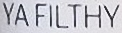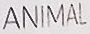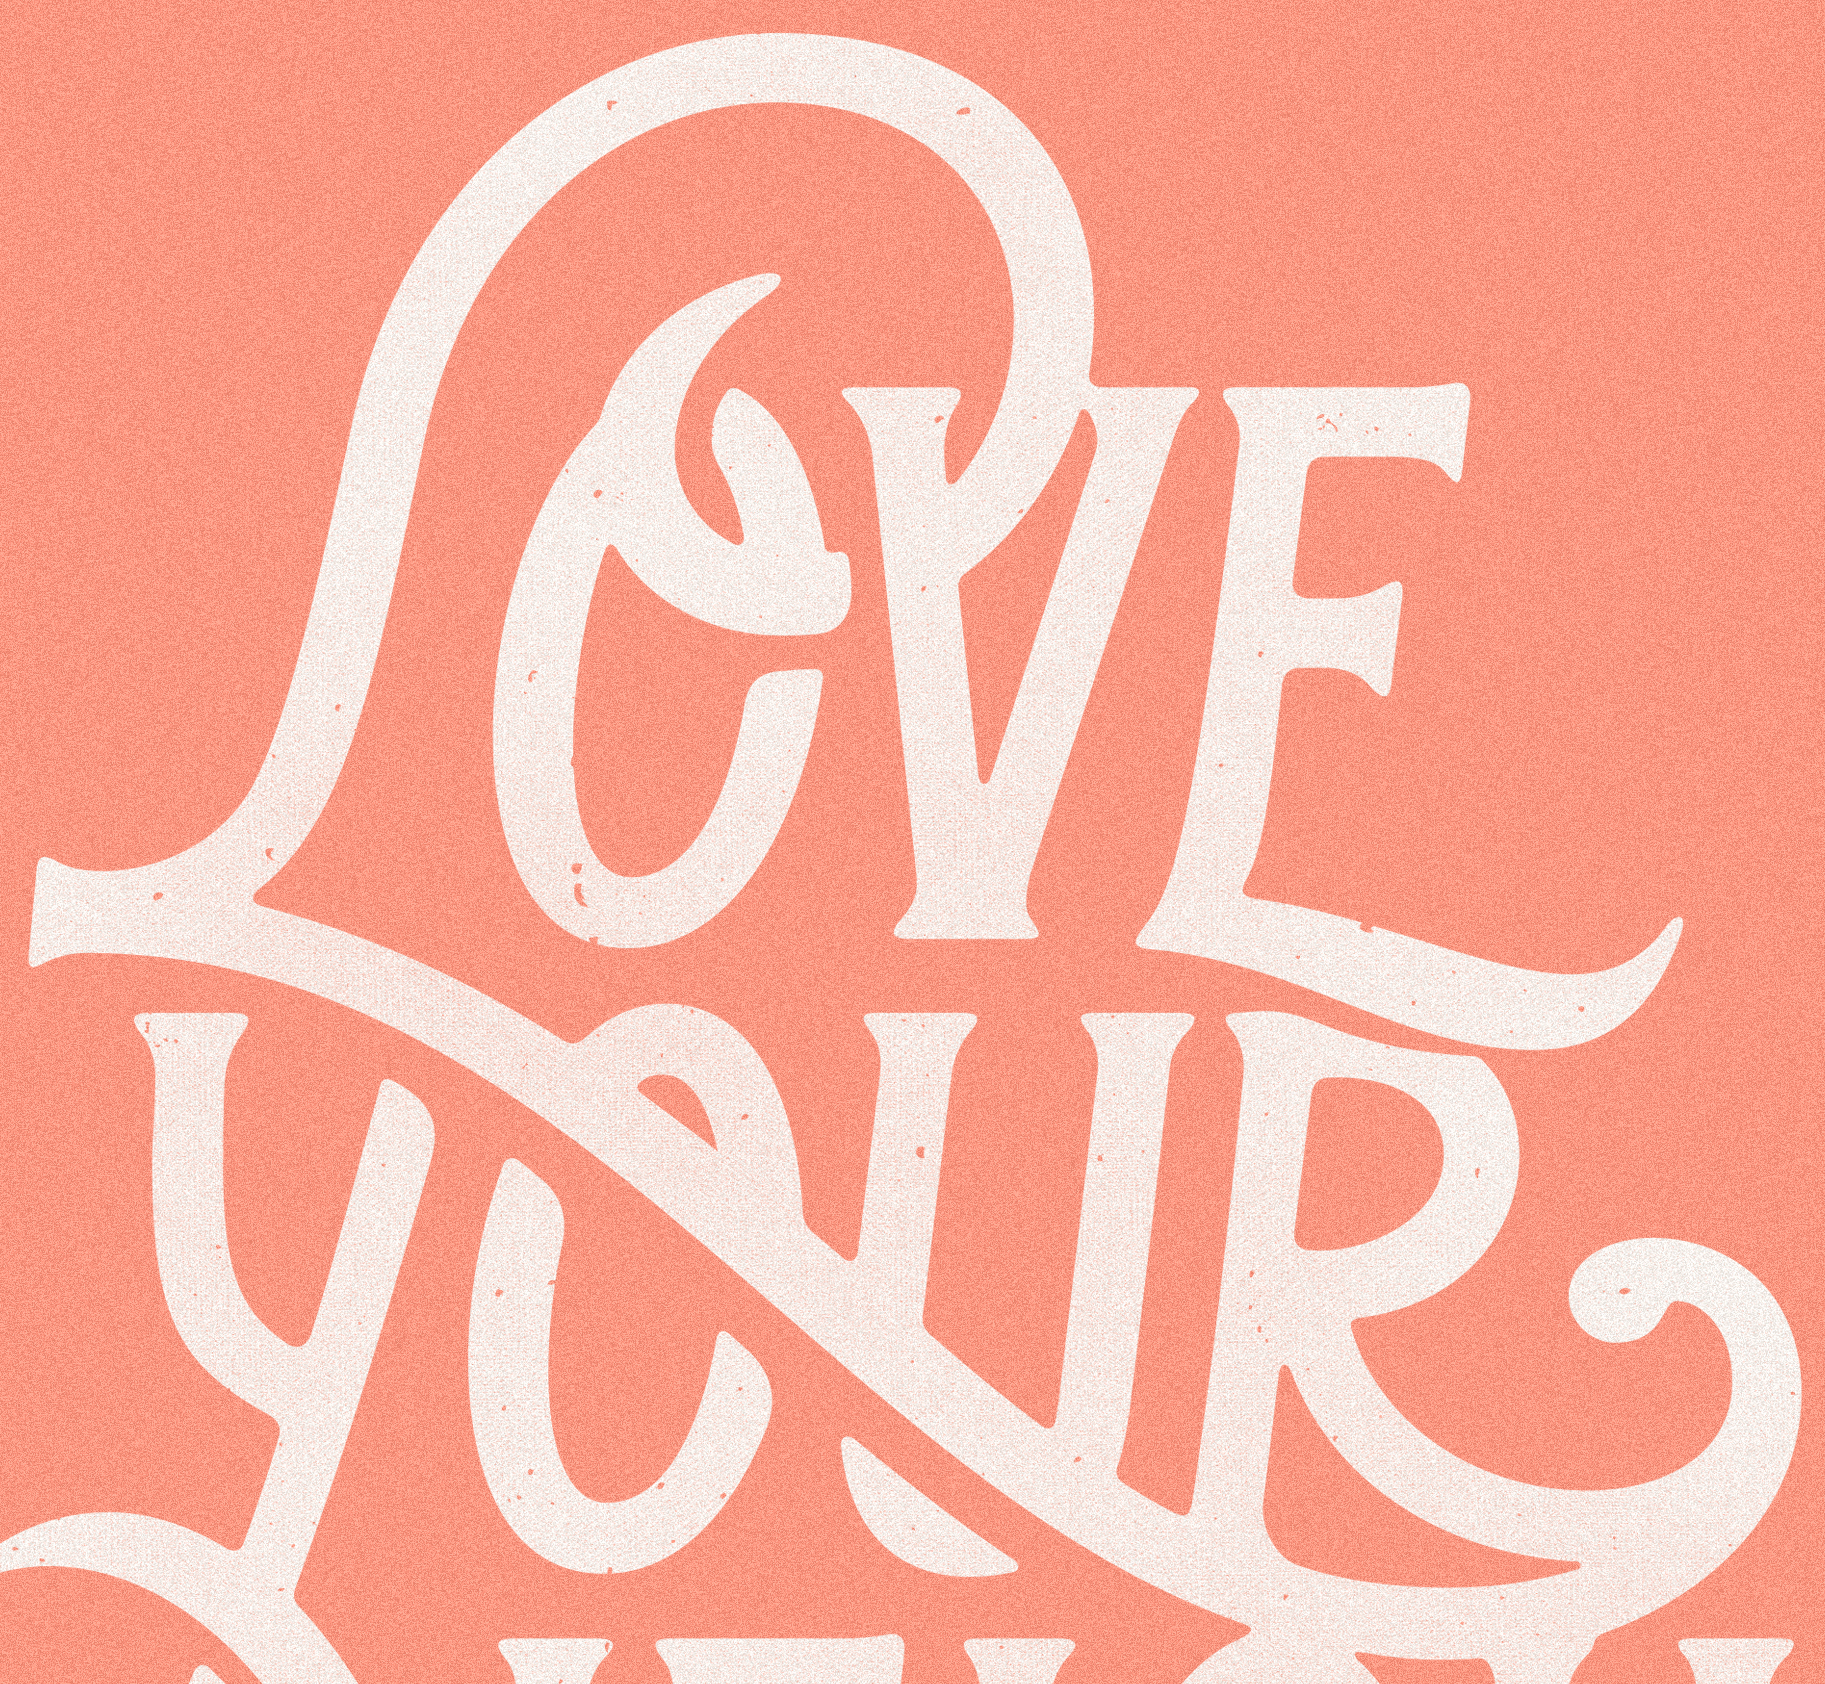Identify the words shown in these images in order, separated by a semicolon. YAFILTHY; ANIMAL; LOVE 